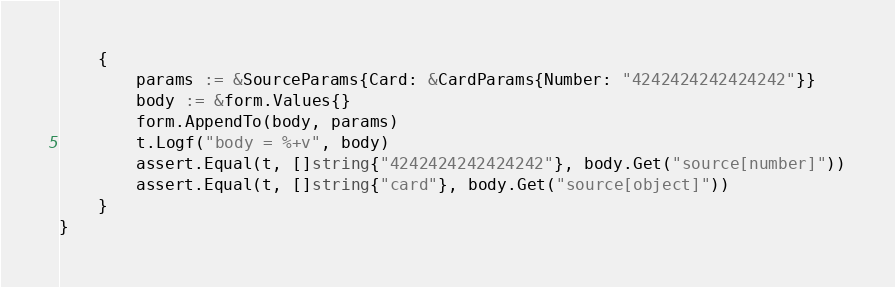<code> <loc_0><loc_0><loc_500><loc_500><_Go_>	{
		params := &SourceParams{Card: &CardParams{Number: "4242424242424242"}}
		body := &form.Values{}
		form.AppendTo(body, params)
		t.Logf("body = %+v", body)
		assert.Equal(t, []string{"4242424242424242"}, body.Get("source[number]"))
		assert.Equal(t, []string{"card"}, body.Get("source[object]"))
	}
}
</code> 